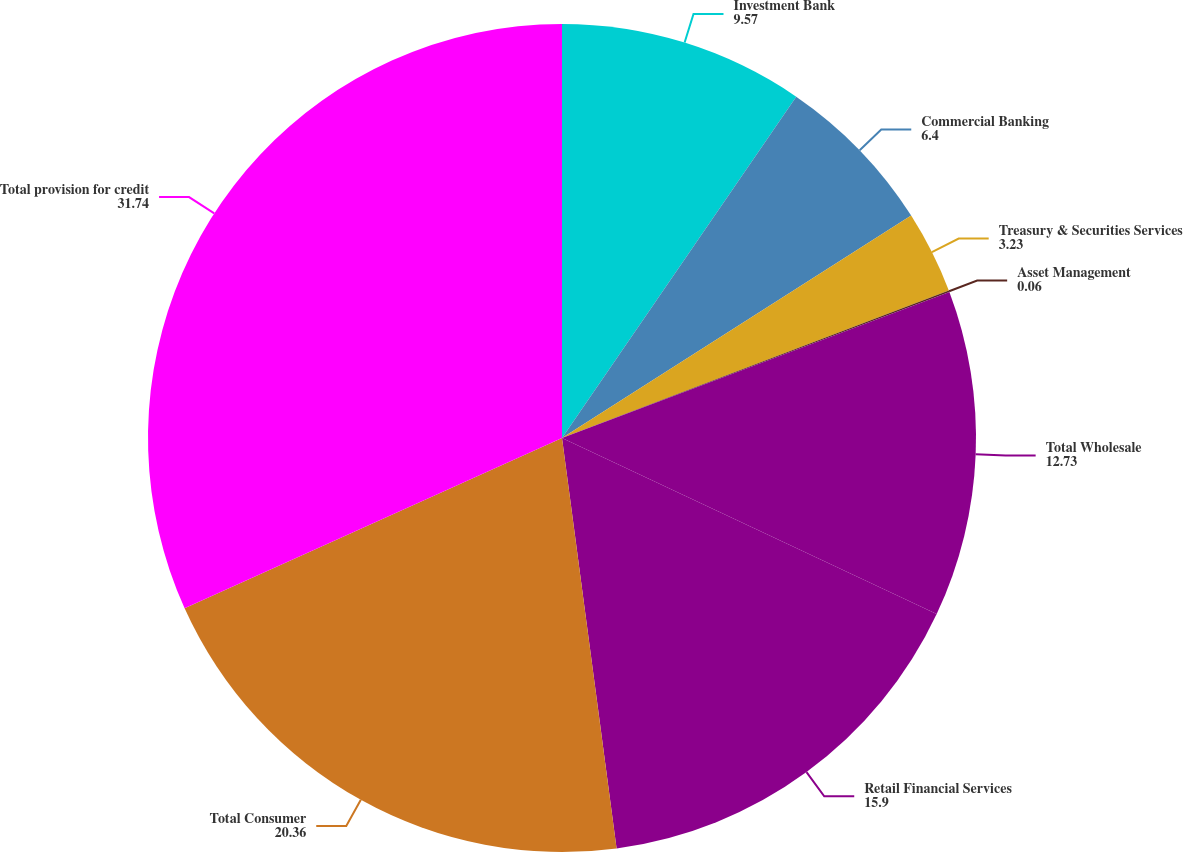<chart> <loc_0><loc_0><loc_500><loc_500><pie_chart><fcel>Investment Bank<fcel>Commercial Banking<fcel>Treasury & Securities Services<fcel>Asset Management<fcel>Total Wholesale<fcel>Retail Financial Services<fcel>Total Consumer<fcel>Total provision for credit<nl><fcel>9.57%<fcel>6.4%<fcel>3.23%<fcel>0.06%<fcel>12.73%<fcel>15.9%<fcel>20.36%<fcel>31.74%<nl></chart> 